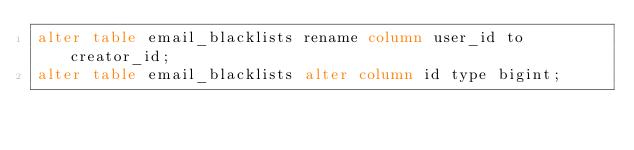Convert code to text. <code><loc_0><loc_0><loc_500><loc_500><_SQL_>alter table email_blacklists rename column user_id to creator_id;
alter table email_blacklists alter column id type bigint;</code> 